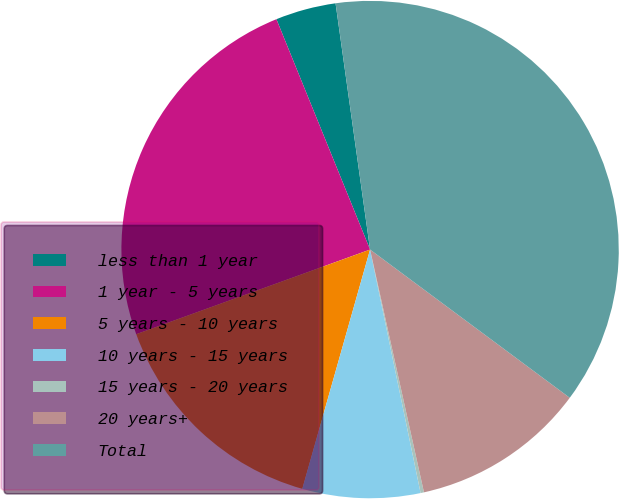<chart> <loc_0><loc_0><loc_500><loc_500><pie_chart><fcel>less than 1 year<fcel>1 year - 5 years<fcel>5 years - 10 years<fcel>10 years - 15 years<fcel>15 years - 20 years<fcel>20 years+<fcel>Total<nl><fcel>3.93%<fcel>24.38%<fcel>15.08%<fcel>7.65%<fcel>0.22%<fcel>11.36%<fcel>37.38%<nl></chart> 